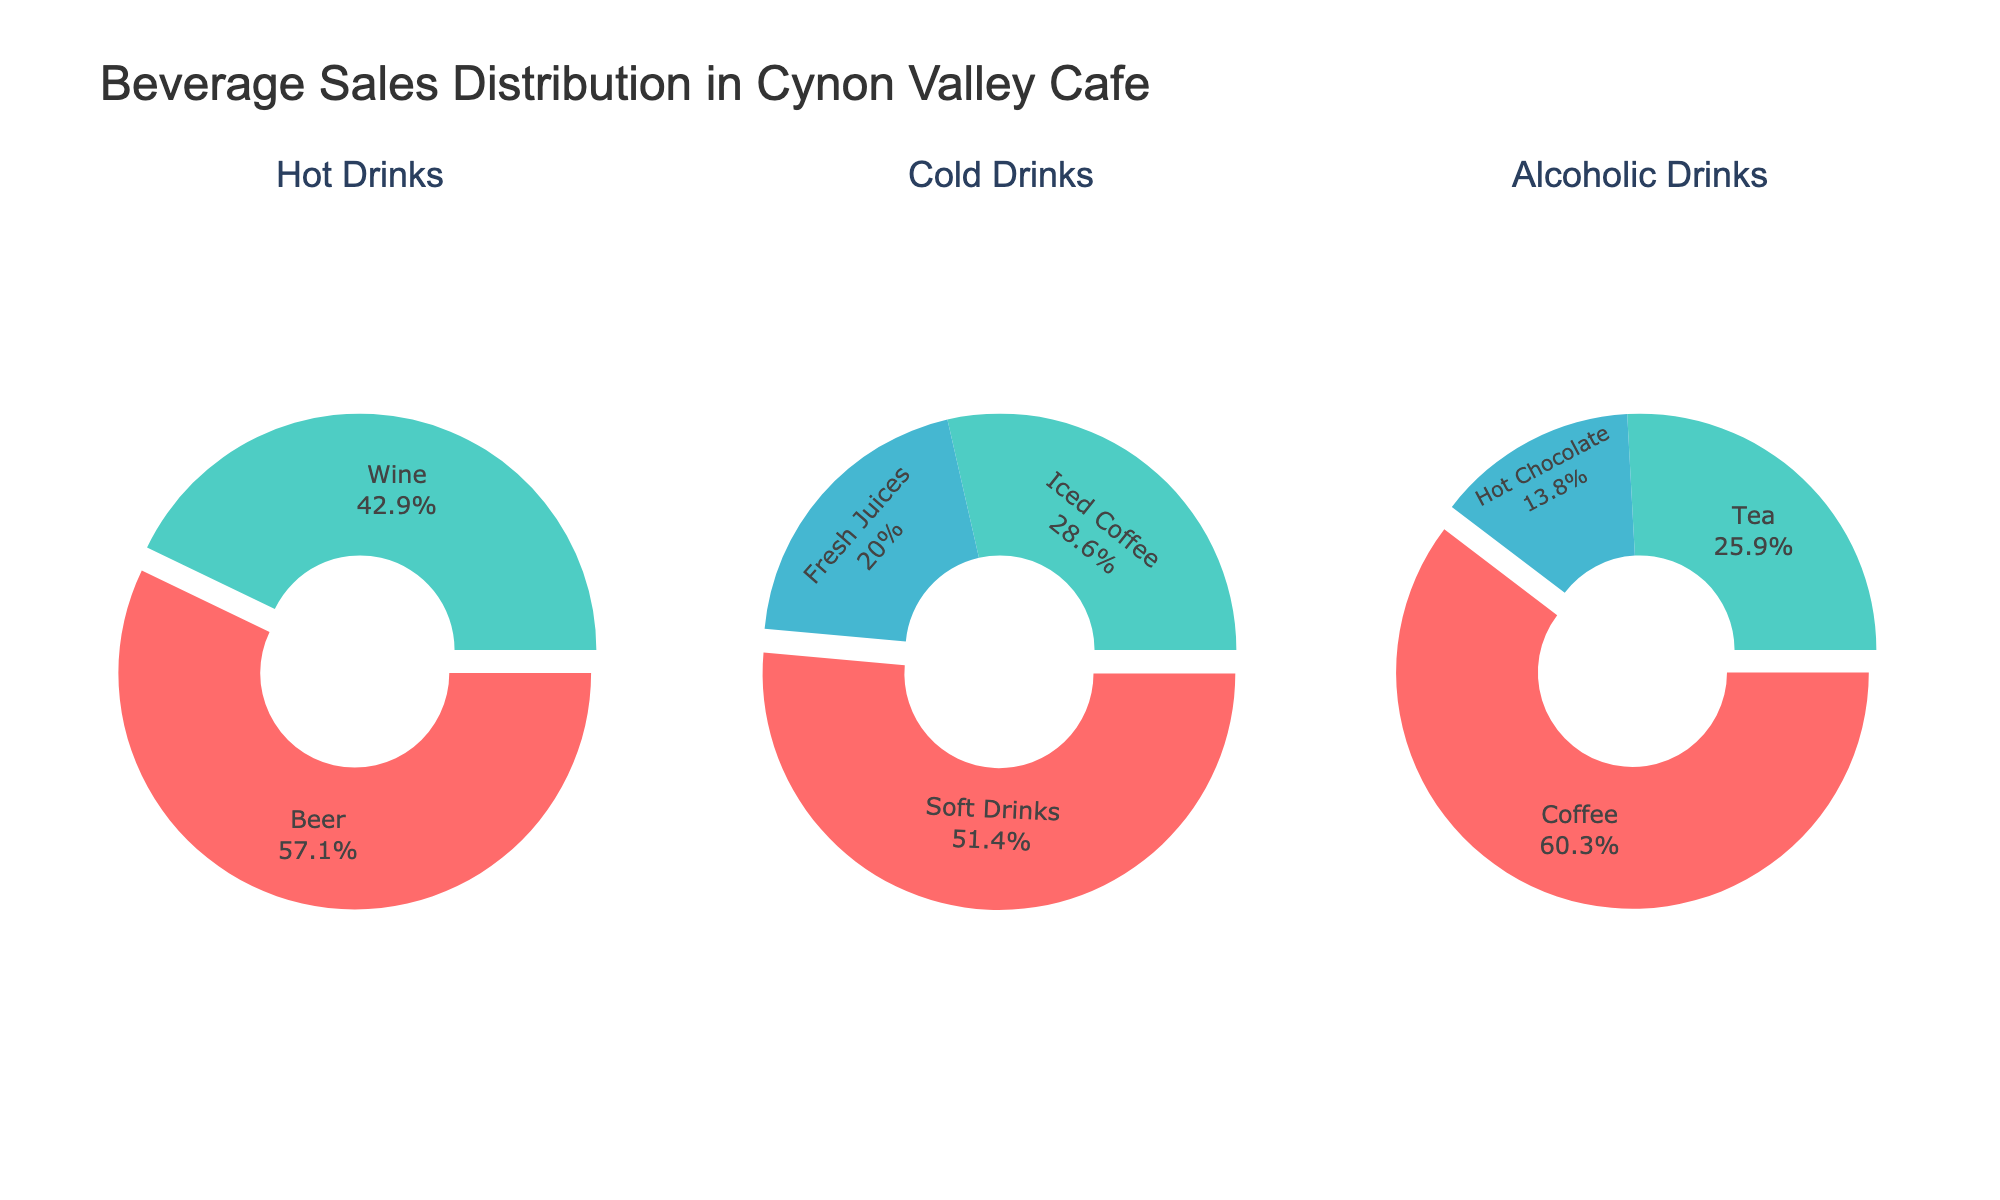What percentage of the total beverage sales is coffee? To find the percentage of coffee sales, look at the "Hot Drinks" pie chart and see that coffee accounts for 35%.
Answer: 35% What is the combined percentage of all hot drinks sold? Sum the percentages of coffee (35%), tea (15%), and hot chocolate (8%). 35 + 15 + 8 = 58%.
Answer: 58% Which category has the smallest percentage of beverage sales? Compare the percentages in the "Hot Drinks," "Cold Drinks," and "Alcoholic Drinks" pie charts. Alcoholic drinks (beer 4%, wine 3%) have the combined smallest percentage of 7%.
Answer: Alcoholic Drinks Which is more popular, soft drinks or iced coffee? Compare the percentages in the "Cold Drinks" pie chart. Soft drinks account for 18%, whereas iced coffee accounts for 10%. Soft drinks have a higher percentage.
Answer: Soft drinks What is the difference in percentage between tea and fresh juices? Check the "Hot Drinks" pie chart for tea (15%) and the "Cold Drinks" chart for fresh juices (7%). The difference is 15 - 7 = 8%.
Answer: 8% Which has a higher percentage, wine or hot chocolate? Compare the "Hot Drinks" pie chart for hot chocolate (8%) and the "Alcoholic Drinks" pie chart for wine (3%). Hot chocolate has a higher percentage.
Answer: Hot chocolate What percentage of the total beverage sales is from cold drinks? Sum the percentages of cold drinks: soft drinks (18%), iced coffee (10%), and fresh juices (7%). 18 + 10 + 7 = 35%.
Answer: 35% How does the percentage of soft drink sales compare to coffee sales? Check both percentages: coffee is 35% and soft drinks are 18%. Coffee has a higher percentage.
Answer: Coffee has a higher percentage 